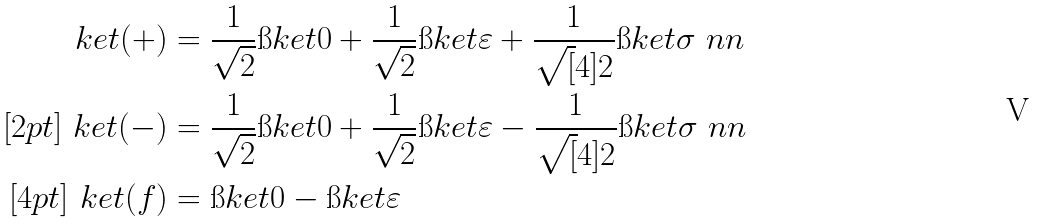<formula> <loc_0><loc_0><loc_500><loc_500>\ k e t { ( + ) } & = \frac { 1 } { \sqrt { 2 } } \i k e t { 0 } + \frac { 1 } { \sqrt { 2 } } \i k e t { \varepsilon } + \frac { 1 } { \sqrt { [ } 4 ] { 2 } } \i k e t { \sigma } \ n n \\ [ 2 p t ] \ k e t { ( - ) } & = \frac { 1 } { \sqrt { 2 } } \i k e t { 0 } + \frac { 1 } { \sqrt { 2 } } \i k e t { \varepsilon } - \frac { 1 } { \sqrt { [ } 4 ] { 2 } } \i k e t { \sigma } \ n n \\ [ 4 p t ] \ k e t { ( f ) } & = \i k e t { 0 } - \i k e t { \varepsilon }</formula> 